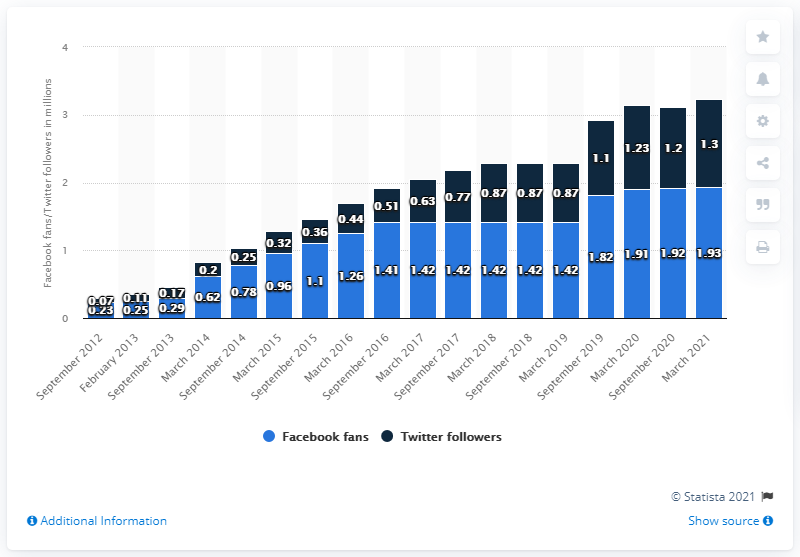Point out several critical features in this image. As of March 2021, the Milwaukee Bucks basketball team had 1.93 million Facebook followers. 